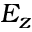<formula> <loc_0><loc_0><loc_500><loc_500>E _ { z }</formula> 